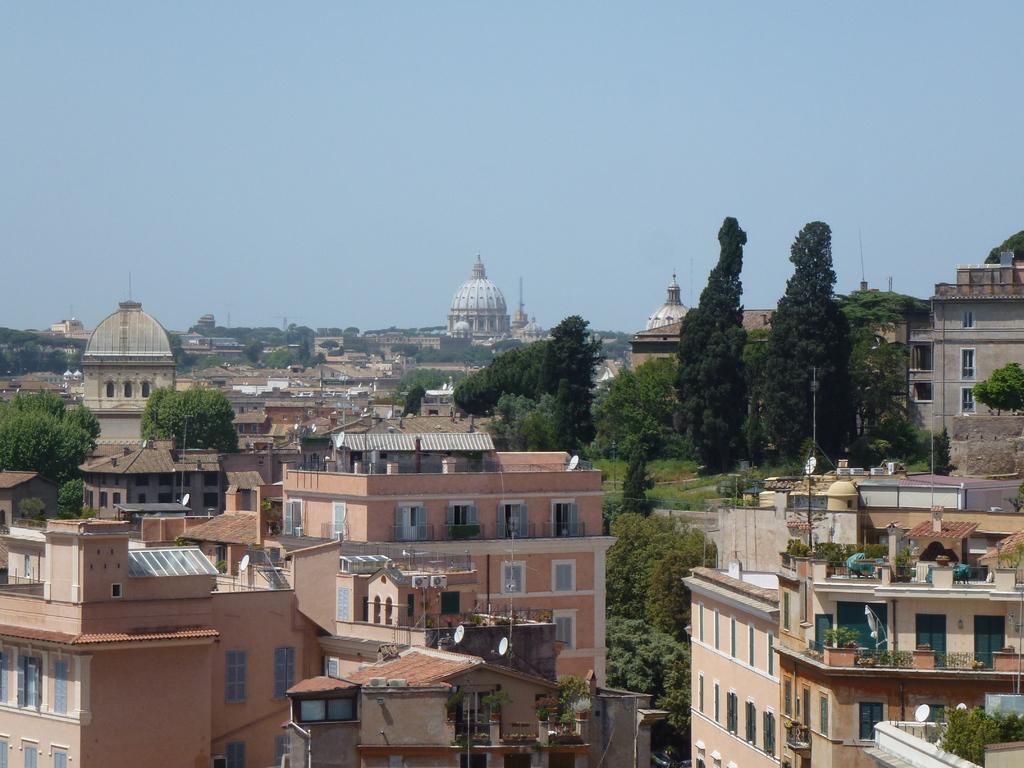What type of natural elements can be seen in the image? There are trees in the image. What type of man-made structures are present in the image? There are buildings in the image. What is visible at the top of the image? The sky is visible at the top of the image. What type of string can be seen connecting the trees in the image? There is no string connecting the trees in the image; only trees and buildings are present. What type of wood is used to construct the buildings in the image? The image does not provide information about the materials used to construct the buildings, so it cannot be determined from the image. 